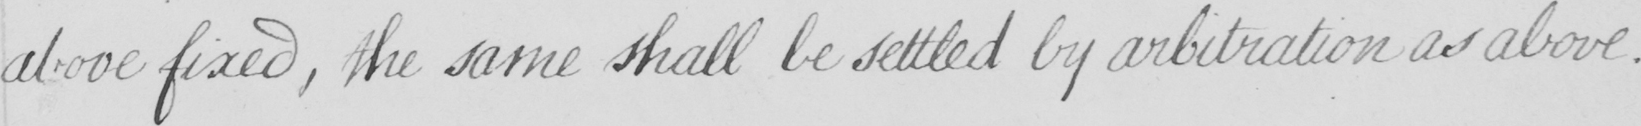Can you tell me what this handwritten text says? above fixed , the same shall be settled by arbitration as above . 